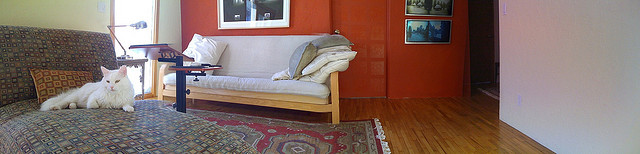What kind of space is depicted in the image? The image shows a cozy and warmly lit living room with hardwood floors, complemented by a rich, red wall. There is a sofa, a patterned rug, and a white cat enjoying the comfort of the space. Can you tell me more about the decoration style? The decoration style has a contemporary feel, with minimal, yet homey touches. Earthy colors are prominent, with the bold red wall making a statement. The patterns on the rug add texture and visual interest. Overall, it's a stylish yet inviting space. 